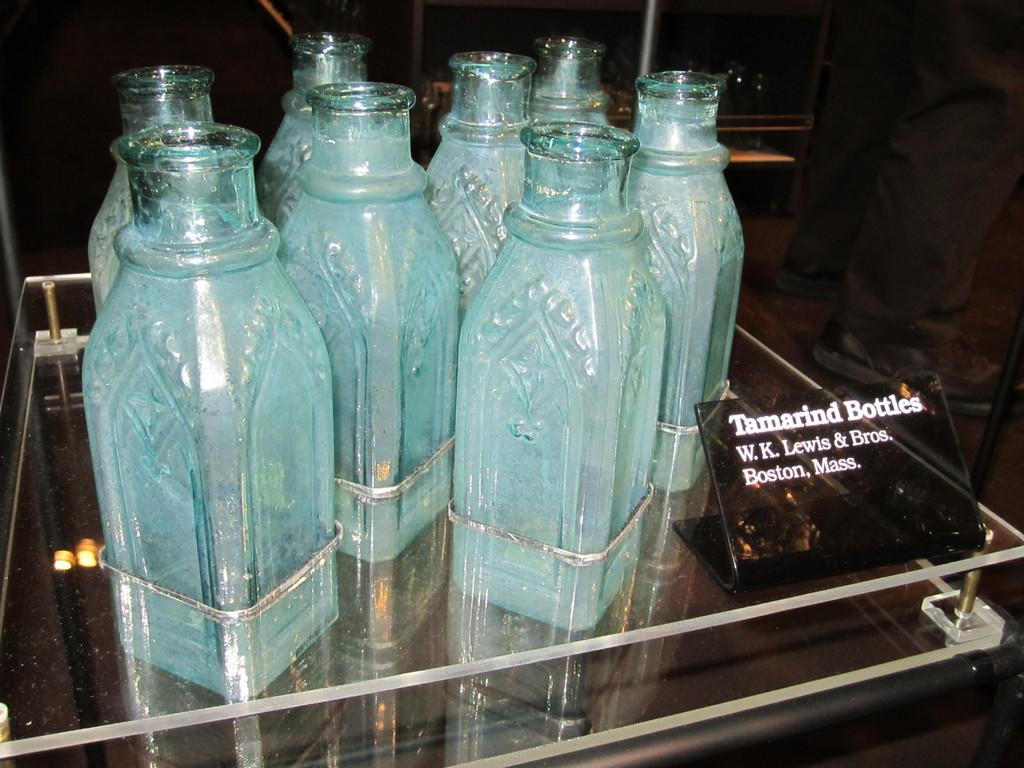<image>
Describe the image concisely. Vintage Tamarind Bottles W.K. Lewis & Bros. Boston, Mass. 